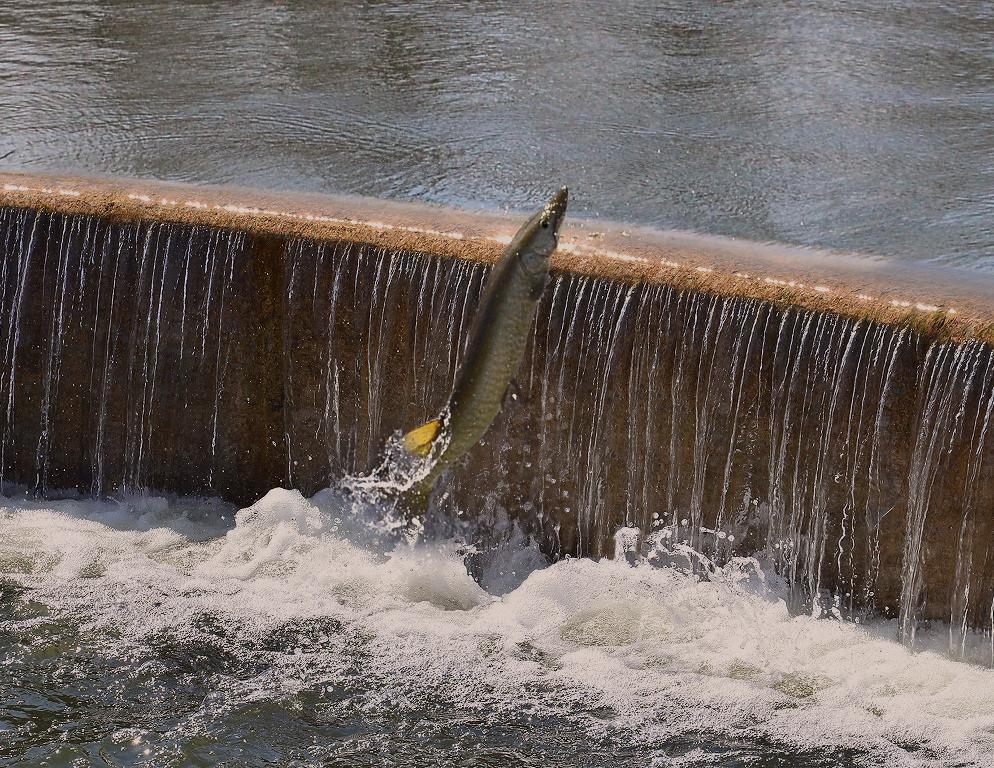How would you summarize this image in a sentence or two? In the picture we can see a water fall and from it we can see a fish coming out which is gray in color. 